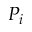Convert formula to latex. <formula><loc_0><loc_0><loc_500><loc_500>P _ { i }</formula> 